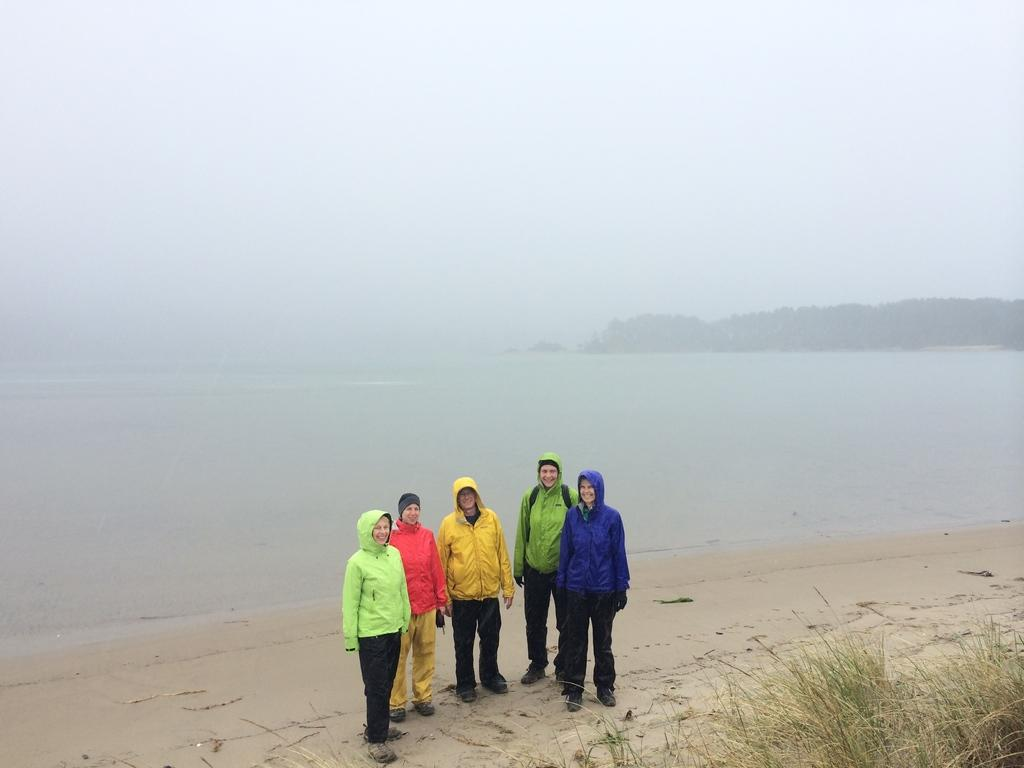What type of natural environment is depicted in the image? There is a sea shore in the image. What are the people on the sea shore wearing? The people on the sea shore are wearing jackets. What other natural elements can be seen in the image? There are plants visible in the image. What type of landscape feature is present in the background? There are mountains in the image. Can you tell me how many friends the person on the sea shore has in the image? There is no information about friends or any specific person in the image, so it cannot be determined. What direction are the mountains turning in the image? Mountains do not turn; they are stationary landscape features, and there is no indication of any movement in the image. 